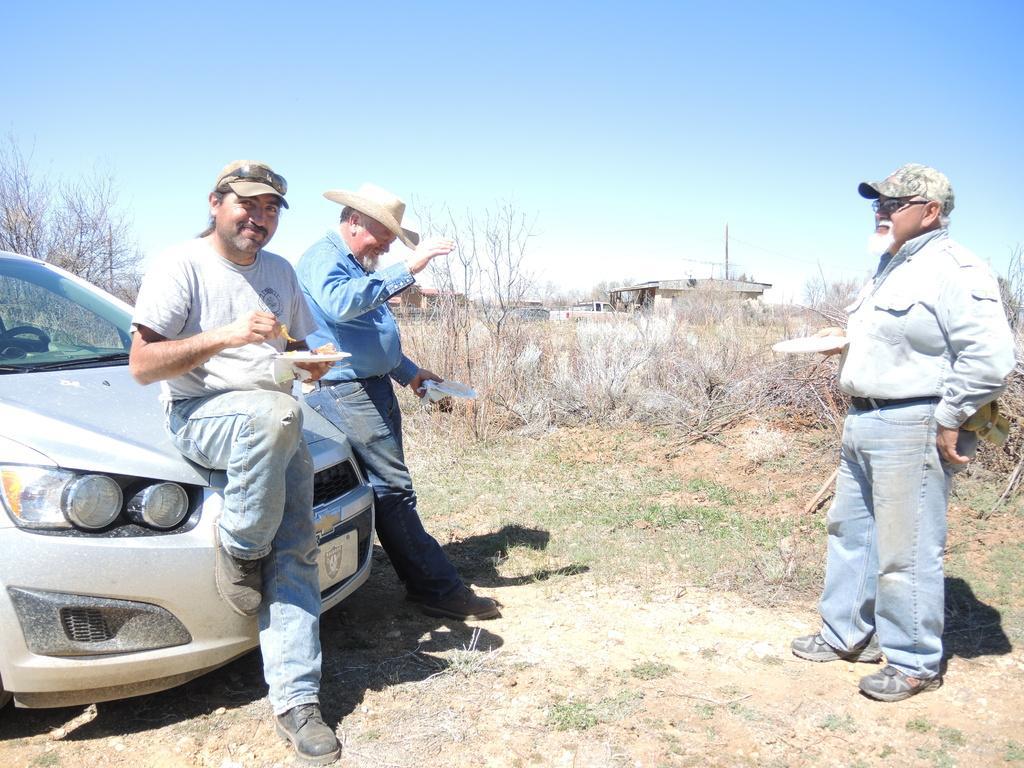Can you describe this image briefly? In the foreground of this image, there are two man leaning on a car holding a platter, and few objects. On the right, there is a man standing and holding a platter on the ground. In the background, there are plants, trees, few buildings, a pole and the sky. 